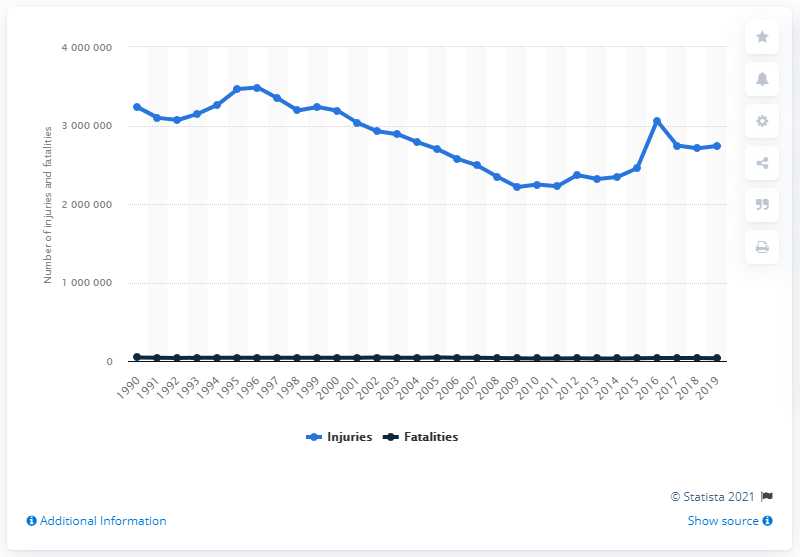Draw attention to some important aspects in this diagram. During the period between 2010 and 2019, there were approximately 274,000 road traffic-related injuries. 